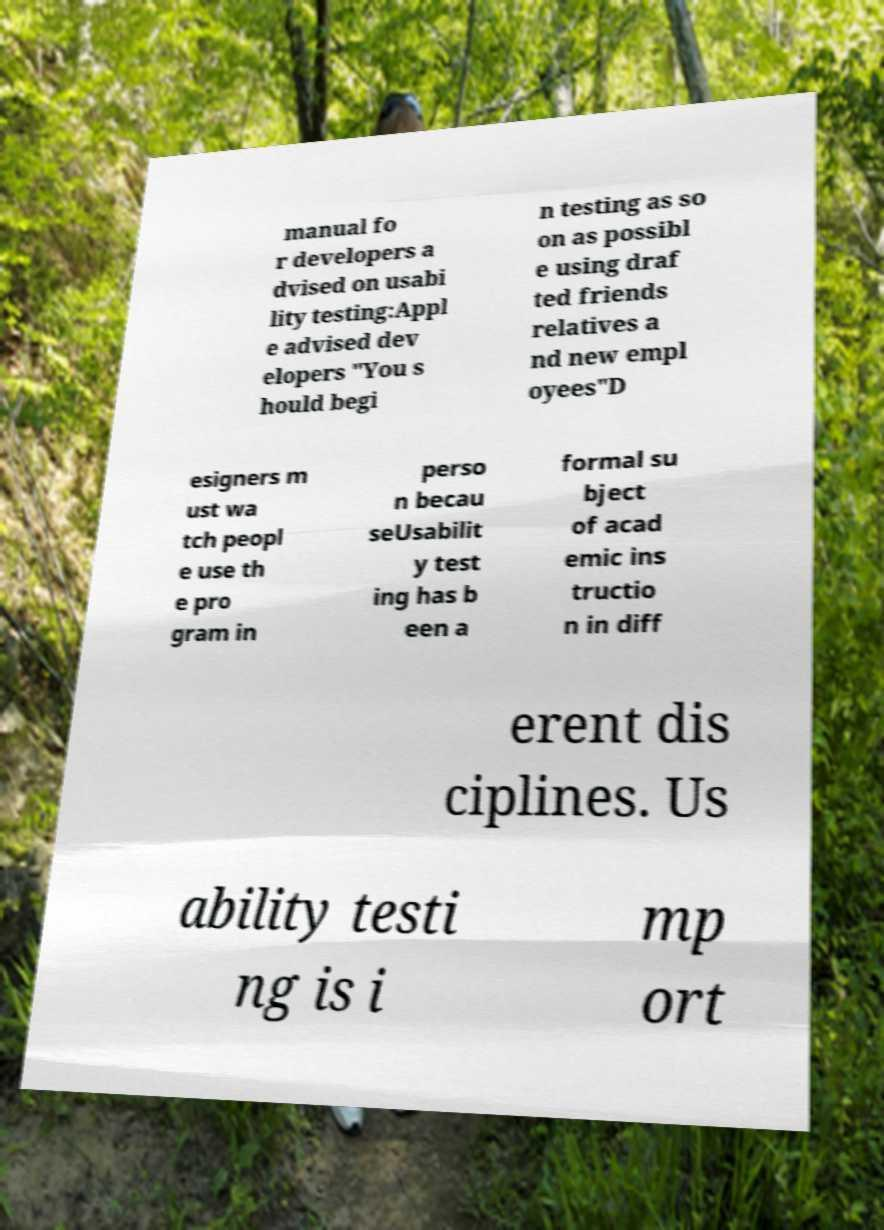There's text embedded in this image that I need extracted. Can you transcribe it verbatim? manual fo r developers a dvised on usabi lity testing:Appl e advised dev elopers "You s hould begi n testing as so on as possibl e using draf ted friends relatives a nd new empl oyees"D esigners m ust wa tch peopl e use th e pro gram in perso n becau seUsabilit y test ing has b een a formal su bject of acad emic ins tructio n in diff erent dis ciplines. Us ability testi ng is i mp ort 